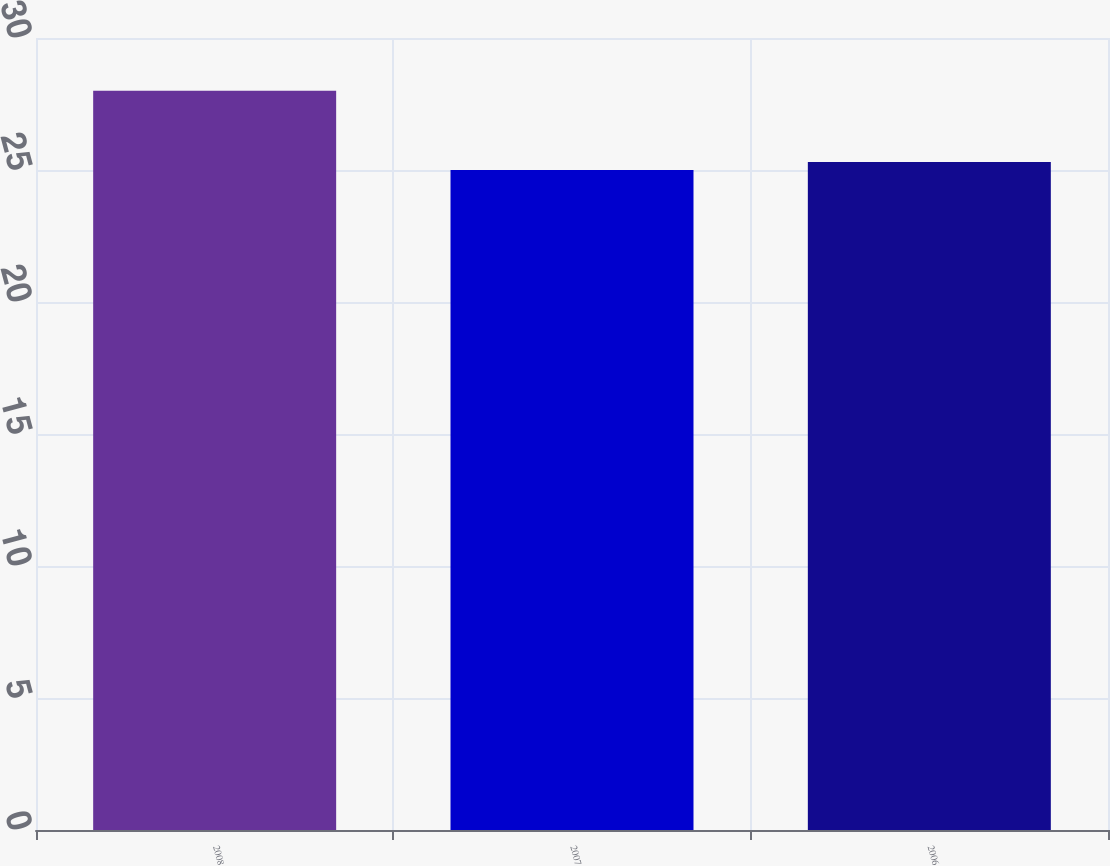<chart> <loc_0><loc_0><loc_500><loc_500><bar_chart><fcel>2008<fcel>2007<fcel>2006<nl><fcel>28<fcel>25<fcel>25.3<nl></chart> 